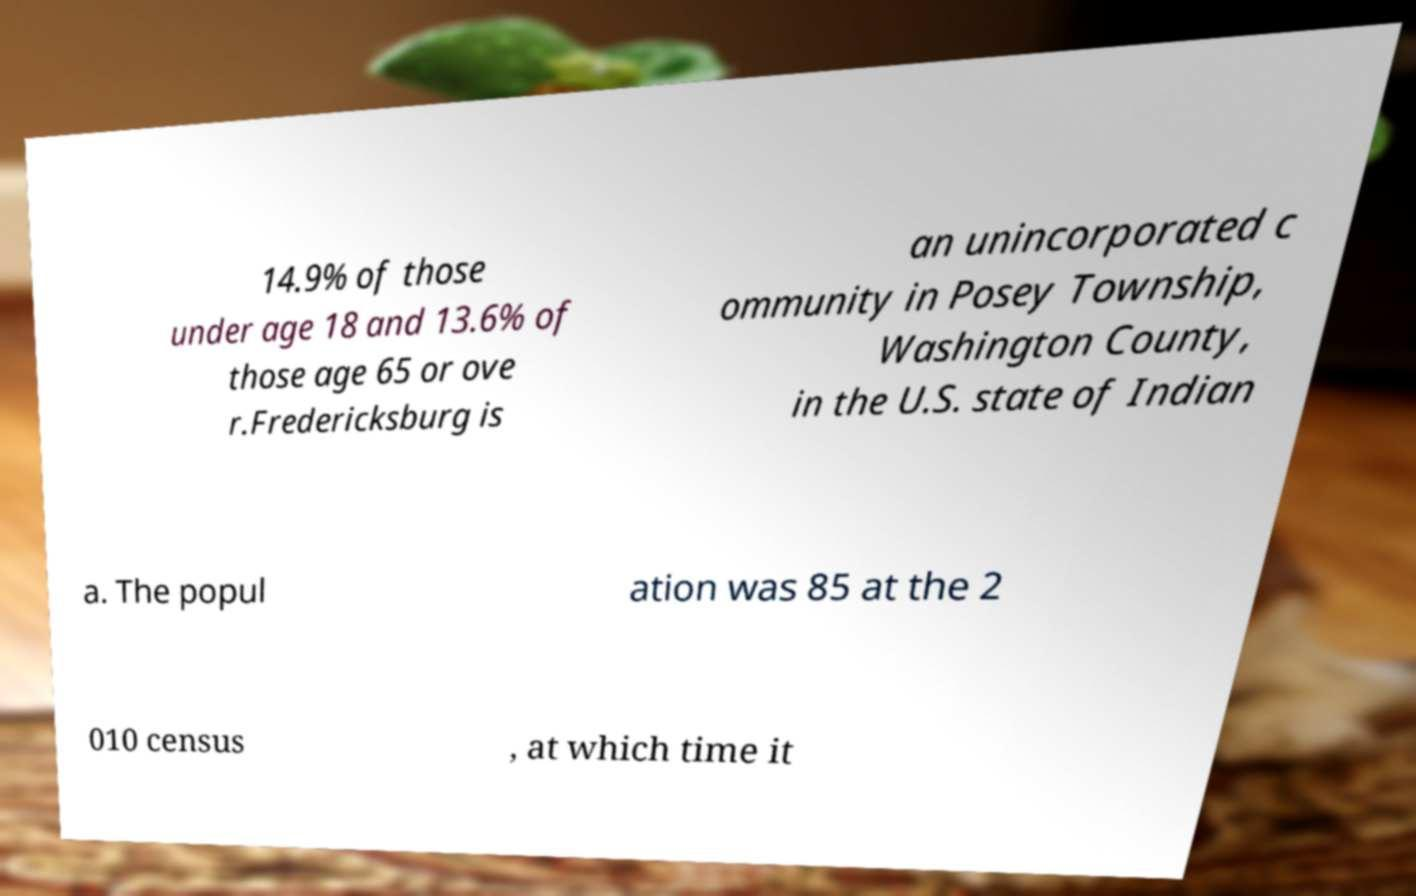Can you accurately transcribe the text from the provided image for me? 14.9% of those under age 18 and 13.6% of those age 65 or ove r.Fredericksburg is an unincorporated c ommunity in Posey Township, Washington County, in the U.S. state of Indian a. The popul ation was 85 at the 2 010 census , at which time it 